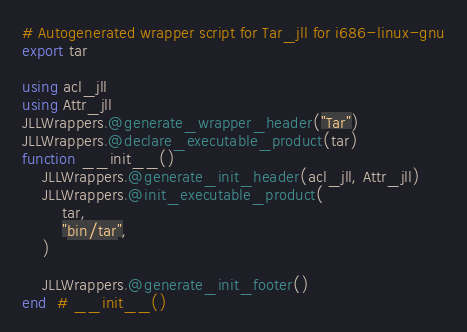Convert code to text. <code><loc_0><loc_0><loc_500><loc_500><_Julia_># Autogenerated wrapper script for Tar_jll for i686-linux-gnu
export tar

using acl_jll
using Attr_jll
JLLWrappers.@generate_wrapper_header("Tar")
JLLWrappers.@declare_executable_product(tar)
function __init__()
    JLLWrappers.@generate_init_header(acl_jll, Attr_jll)
    JLLWrappers.@init_executable_product(
        tar,
        "bin/tar",
    )

    JLLWrappers.@generate_init_footer()
end  # __init__()
</code> 